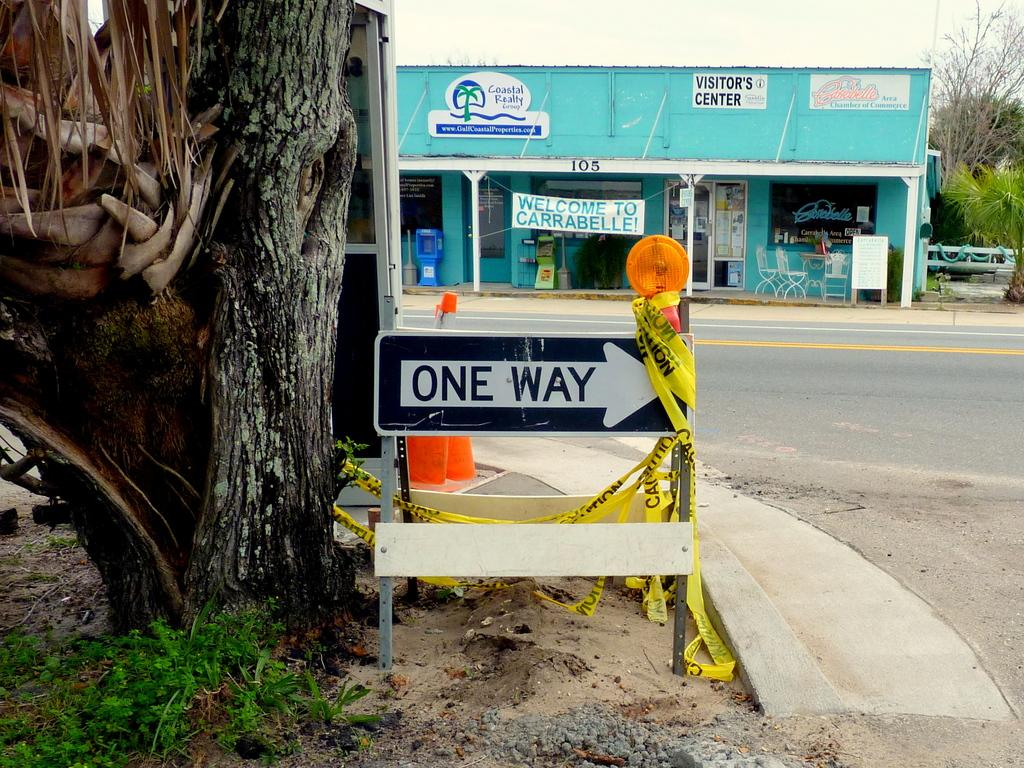What type of plant can be seen in the image? There is a tree in the image. What is located on the footpath in the image? There is a sign board on the footpath. What type of structure is present in the image? There is a building in the image. What type of furniture is visible outside the building? Chairs are kept outside the building. How many types of plants can be seen in the image? There are at least two types of plants, as there is a tree and other trees visible in the image. Can you see a gun being held by the queen in the image? There is no gun or queen present in the image. What type of vegetable is being used as a decoration in the image? There is no vegetable, such as a potato, being used as a decoration in the image. 